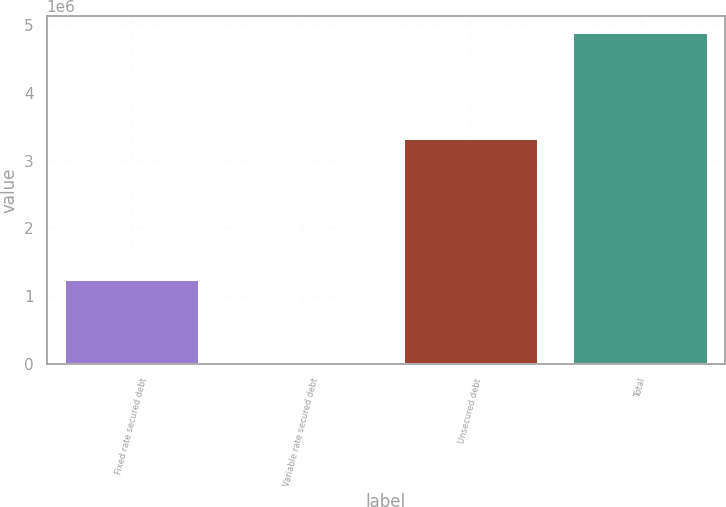<chart> <loc_0><loc_0><loc_500><loc_500><bar_chart><fcel>Fixed rate secured debt<fcel>Variable rate secured debt<fcel>Unsecured debt<fcel>Total<nl><fcel>1.25148e+06<fcel>18386<fcel>3.33639e+06<fcel>4.89188e+06<nl></chart> 